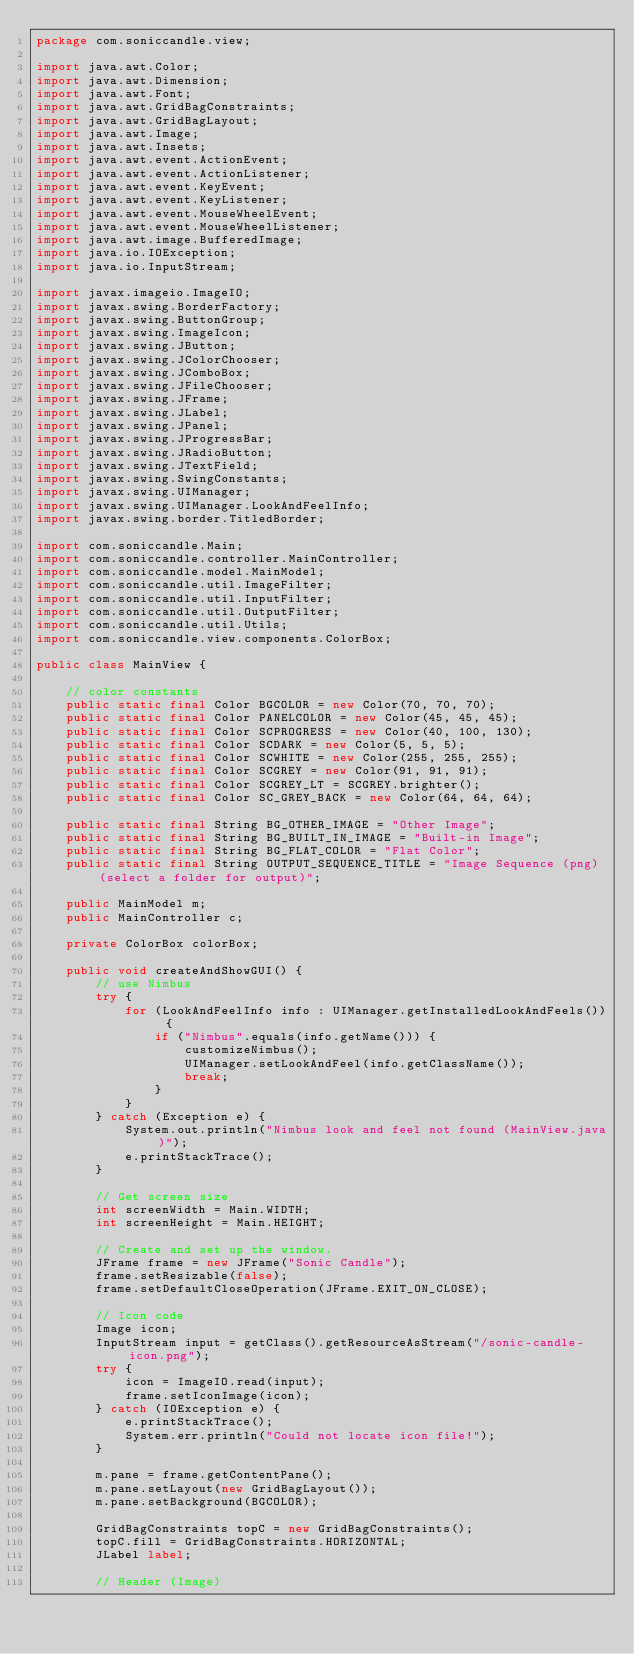<code> <loc_0><loc_0><loc_500><loc_500><_Java_>package com.soniccandle.view;

import java.awt.Color;
import java.awt.Dimension;
import java.awt.Font;
import java.awt.GridBagConstraints;
import java.awt.GridBagLayout;
import java.awt.Image;
import java.awt.Insets;
import java.awt.event.ActionEvent;
import java.awt.event.ActionListener;
import java.awt.event.KeyEvent;
import java.awt.event.KeyListener;
import java.awt.event.MouseWheelEvent;
import java.awt.event.MouseWheelListener;
import java.awt.image.BufferedImage;
import java.io.IOException;
import java.io.InputStream;

import javax.imageio.ImageIO;
import javax.swing.BorderFactory;
import javax.swing.ButtonGroup;
import javax.swing.ImageIcon;
import javax.swing.JButton;
import javax.swing.JColorChooser;
import javax.swing.JComboBox;
import javax.swing.JFileChooser;
import javax.swing.JFrame;
import javax.swing.JLabel;
import javax.swing.JPanel;
import javax.swing.JProgressBar;
import javax.swing.JRadioButton;
import javax.swing.JTextField;
import javax.swing.SwingConstants;
import javax.swing.UIManager;
import javax.swing.UIManager.LookAndFeelInfo;
import javax.swing.border.TitledBorder;

import com.soniccandle.Main;
import com.soniccandle.controller.MainController;
import com.soniccandle.model.MainModel;
import com.soniccandle.util.ImageFilter;
import com.soniccandle.util.InputFilter;
import com.soniccandle.util.OutputFilter;
import com.soniccandle.util.Utils;
import com.soniccandle.view.components.ColorBox;

public class MainView {

    // color constants
    public static final Color BGCOLOR = new Color(70, 70, 70);
    public static final Color PANELCOLOR = new Color(45, 45, 45);
    public static final Color SCPROGRESS = new Color(40, 100, 130);
    public static final Color SCDARK = new Color(5, 5, 5);
    public static final Color SCWHITE = new Color(255, 255, 255);
    public static final Color SCGREY = new Color(91, 91, 91);
    public static final Color SCGREY_LT = SCGREY.brighter();
    public static final Color SC_GREY_BACK = new Color(64, 64, 64);

    public static final String BG_OTHER_IMAGE = "Other Image";
    public static final String BG_BUILT_IN_IMAGE = "Built-in Image";
    public static final String BG_FLAT_COLOR = "Flat Color";
    public static final String OUTPUT_SEQUENCE_TITLE = "Image Sequence (png) (select a folder for output)";

    public MainModel m;
    public MainController c;

    private ColorBox colorBox;

    public void createAndShowGUI() {
        // use Nimbus
        try {
            for (LookAndFeelInfo info : UIManager.getInstalledLookAndFeels()) {
                if ("Nimbus".equals(info.getName())) {
                    customizeNimbus();
                    UIManager.setLookAndFeel(info.getClassName());
                    break;
                }
            }
        } catch (Exception e) {
            System.out.println("Nimbus look and feel not found (MainView.java)");
            e.printStackTrace();
        }

        // Get screen size
        int screenWidth = Main.WIDTH;
        int screenHeight = Main.HEIGHT;

        // Create and set up the window.
        JFrame frame = new JFrame("Sonic Candle");
        frame.setResizable(false);
        frame.setDefaultCloseOperation(JFrame.EXIT_ON_CLOSE);

        // Icon code
        Image icon;
        InputStream input = getClass().getResourceAsStream("/sonic-candle-icon.png");
        try {
            icon = ImageIO.read(input);
            frame.setIconImage(icon);
        } catch (IOException e) {
            e.printStackTrace();
            System.err.println("Could not locate icon file!");
        }

        m.pane = frame.getContentPane();
        m.pane.setLayout(new GridBagLayout());
        m.pane.setBackground(BGCOLOR);

        GridBagConstraints topC = new GridBagConstraints();
        topC.fill = GridBagConstraints.HORIZONTAL;
        JLabel label;

        // Header (Image)</code> 